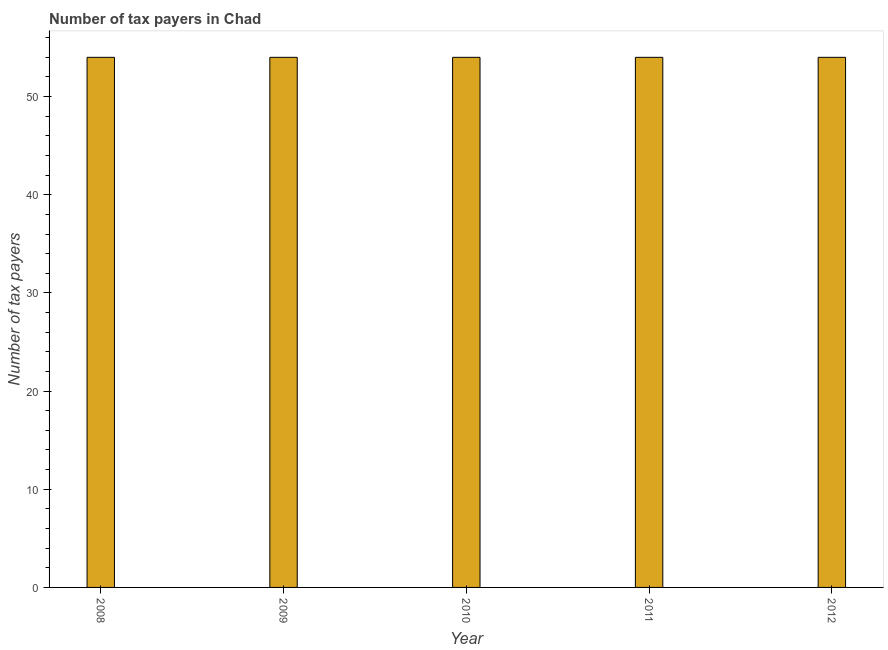What is the title of the graph?
Provide a succinct answer. Number of tax payers in Chad. What is the label or title of the X-axis?
Provide a succinct answer. Year. What is the label or title of the Y-axis?
Make the answer very short. Number of tax payers. What is the number of tax payers in 2009?
Your answer should be very brief. 54. Across all years, what is the minimum number of tax payers?
Make the answer very short. 54. In which year was the number of tax payers maximum?
Keep it short and to the point. 2008. What is the sum of the number of tax payers?
Provide a succinct answer. 270. What is the average number of tax payers per year?
Provide a short and direct response. 54. What is the median number of tax payers?
Ensure brevity in your answer.  54. In how many years, is the number of tax payers greater than 46 ?
Keep it short and to the point. 5. Do a majority of the years between 2011 and 2012 (inclusive) have number of tax payers greater than 30 ?
Offer a terse response. Yes. What is the ratio of the number of tax payers in 2008 to that in 2010?
Give a very brief answer. 1. Is the number of tax payers in 2009 less than that in 2010?
Your answer should be very brief. No. Is the sum of the number of tax payers in 2009 and 2011 greater than the maximum number of tax payers across all years?
Provide a succinct answer. Yes. In how many years, is the number of tax payers greater than the average number of tax payers taken over all years?
Provide a short and direct response. 0. What is the difference between two consecutive major ticks on the Y-axis?
Your response must be concise. 10. Are the values on the major ticks of Y-axis written in scientific E-notation?
Ensure brevity in your answer.  No. What is the Number of tax payers in 2008?
Your answer should be compact. 54. What is the Number of tax payers in 2009?
Provide a succinct answer. 54. What is the Number of tax payers in 2010?
Offer a very short reply. 54. What is the difference between the Number of tax payers in 2008 and 2010?
Provide a short and direct response. 0. What is the difference between the Number of tax payers in 2008 and 2012?
Your answer should be compact. 0. What is the difference between the Number of tax payers in 2011 and 2012?
Make the answer very short. 0. What is the ratio of the Number of tax payers in 2008 to that in 2009?
Offer a very short reply. 1. What is the ratio of the Number of tax payers in 2010 to that in 2011?
Keep it short and to the point. 1. What is the ratio of the Number of tax payers in 2011 to that in 2012?
Provide a succinct answer. 1. 